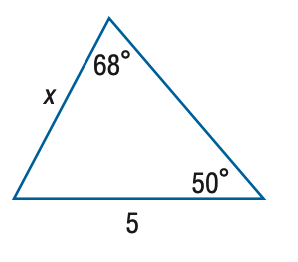Answer the mathemtical geometry problem and directly provide the correct option letter.
Question: Find x. Round side measure to the nearest tenth.
Choices: A: 4.1 B: 4.8 C: 5.3 D: 6.1 A 